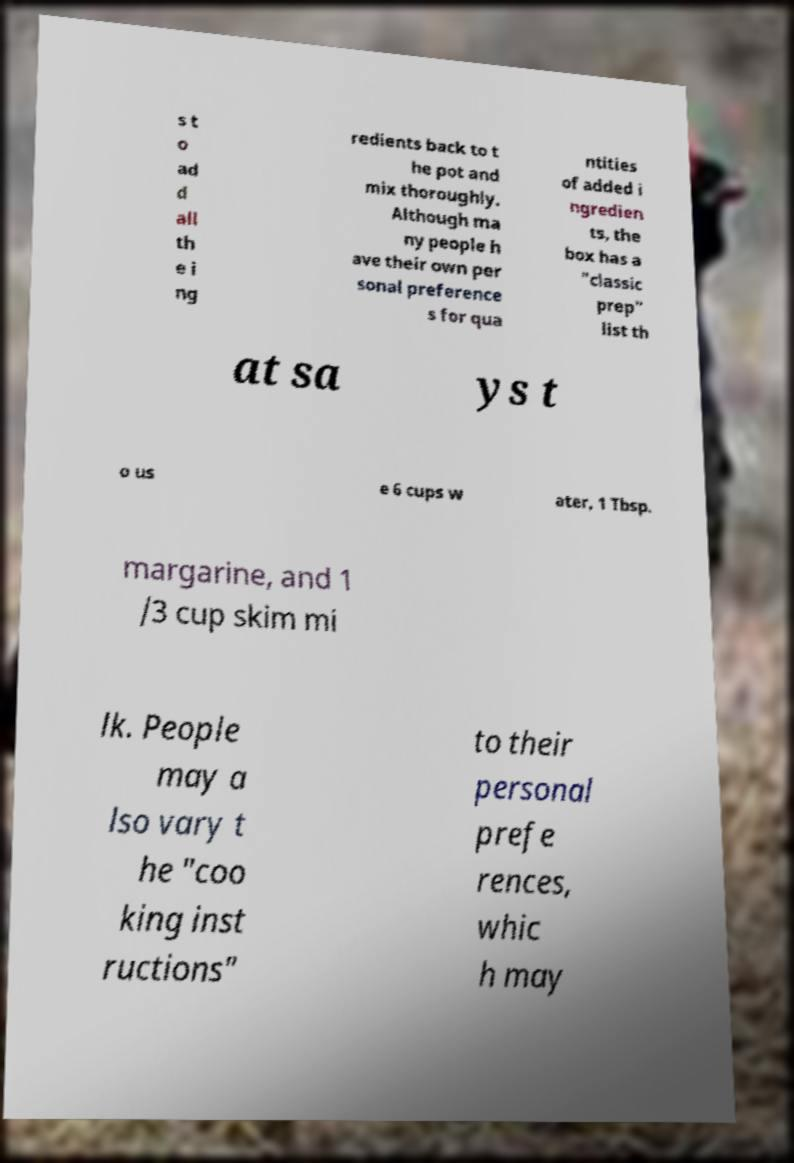Please read and relay the text visible in this image. What does it say? s t o ad d all th e i ng redients back to t he pot and mix thoroughly. Although ma ny people h ave their own per sonal preference s for qua ntities of added i ngredien ts, the box has a "classic prep" list th at sa ys t o us e 6 cups w ater, 1 Tbsp. margarine, and 1 /3 cup skim mi lk. People may a lso vary t he "coo king inst ructions" to their personal prefe rences, whic h may 